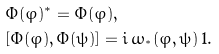<formula> <loc_0><loc_0><loc_500><loc_500>& \Phi ( \varphi ) ^ { \ast } = \Phi ( \varphi ) , \\ & [ \Phi ( \varphi ) , \Phi ( \psi ) ] = i \, \omega _ { ^ { * } } ( \varphi , \psi ) \, 1 .</formula> 